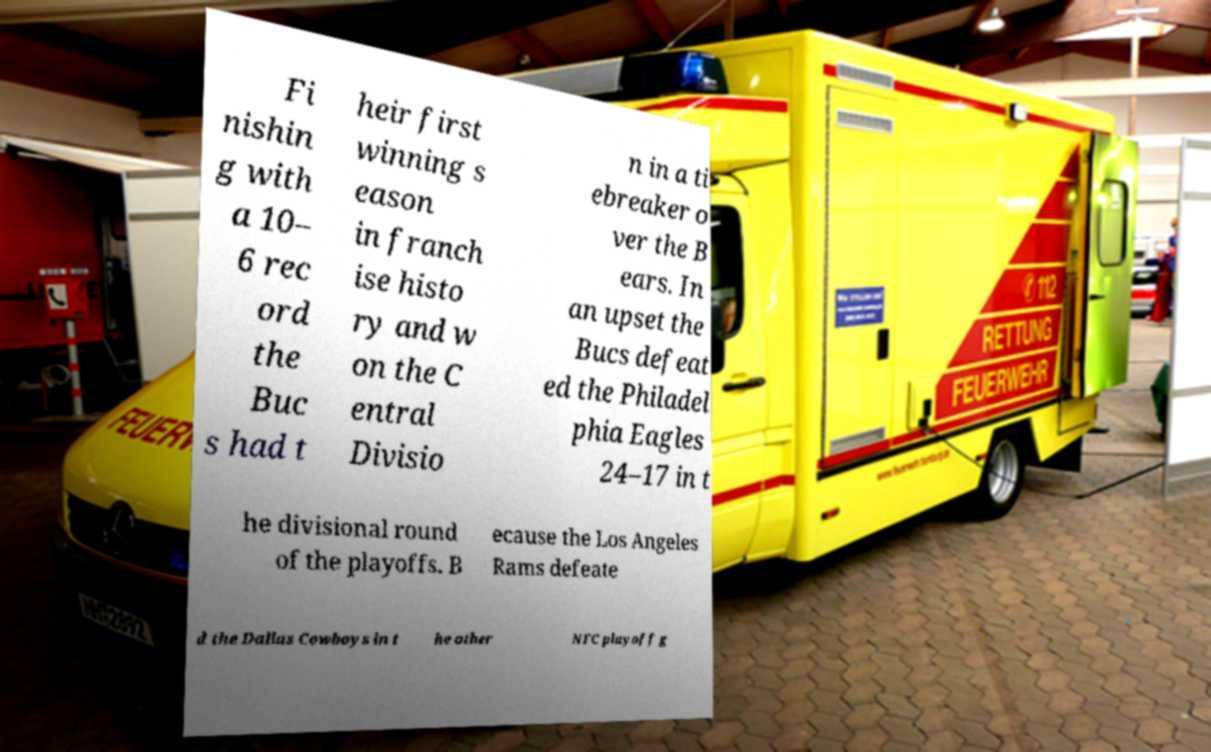Could you extract and type out the text from this image? Fi nishin g with a 10– 6 rec ord the Buc s had t heir first winning s eason in franch ise histo ry and w on the C entral Divisio n in a ti ebreaker o ver the B ears. In an upset the Bucs defeat ed the Philadel phia Eagles 24–17 in t he divisional round of the playoffs. B ecause the Los Angeles Rams defeate d the Dallas Cowboys in t he other NFC playoff g 